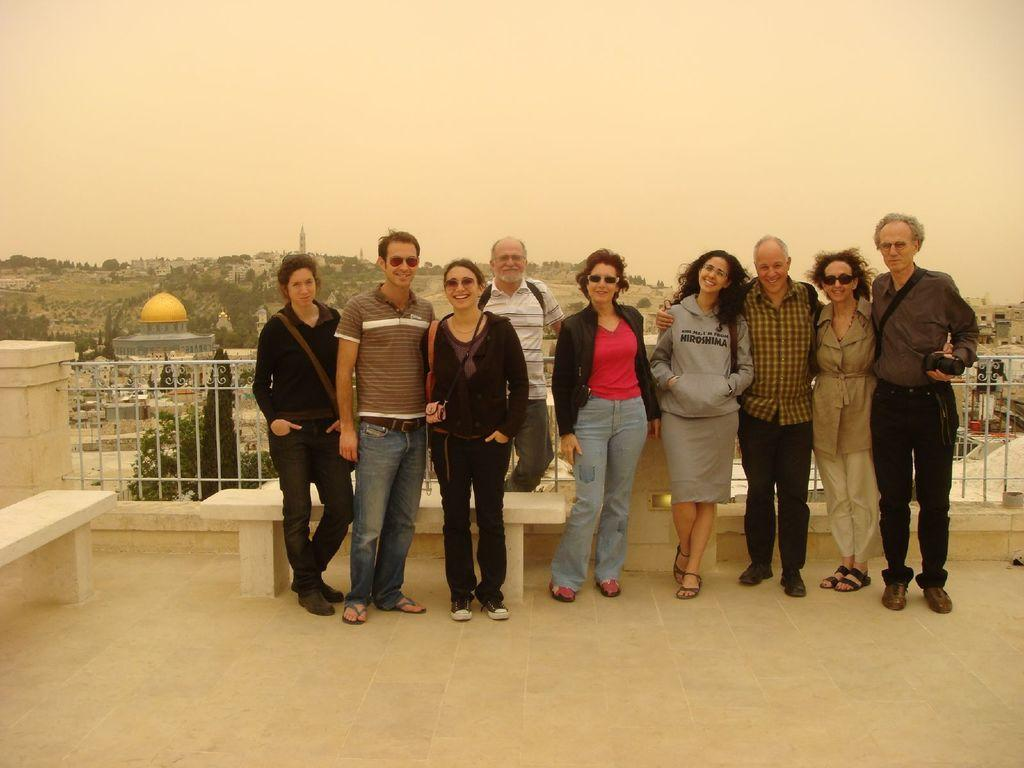What are the people in the image doing? The people in the image are standing. What is the man holding in the image? The man is holding a camera in the image. What can be seen in the background of the image? In the background of the image, there is a fence, a building, trees, and the sky. What type of seating is present in the image? Stone benches are present in the image. What type of drink is the girl holding in the image? There is no girl present in the image, and therefore no drink can be observed. 